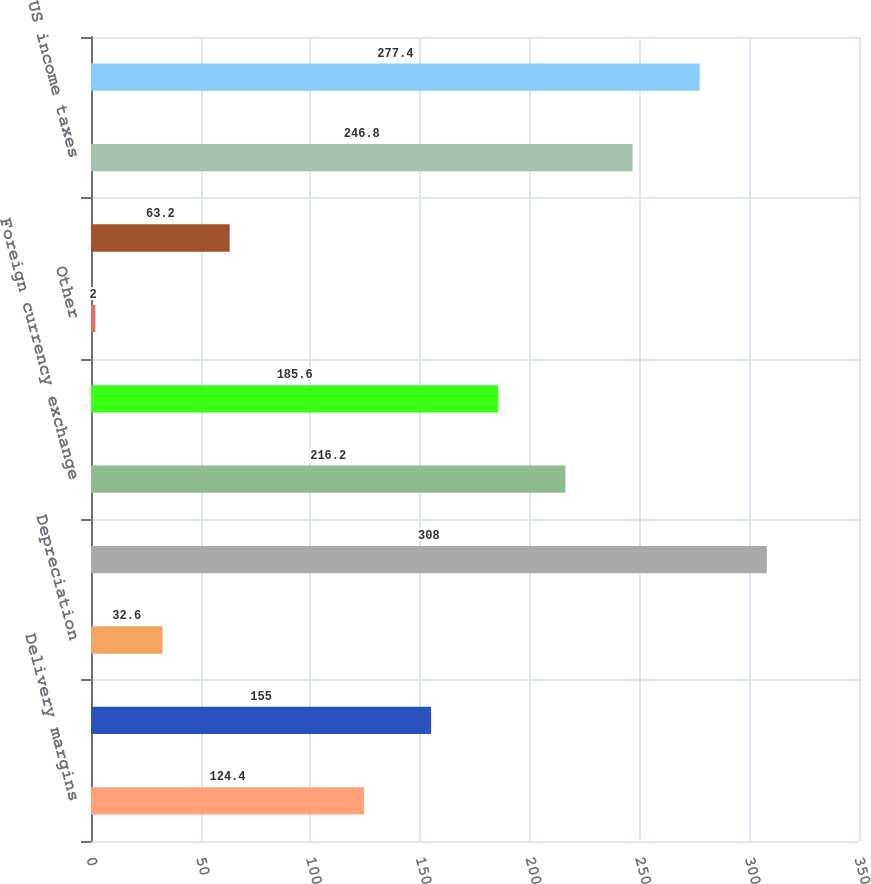Convert chart to OTSL. <chart><loc_0><loc_0><loc_500><loc_500><bar_chart><fcel>Delivery margins<fcel>Other operating expenses<fcel>Depreciation<fcel>Income taxes<fcel>Foreign currency exchange<fcel>Hyder liquidation<fcel>Other<fcel>Discontinued Operations net of<fcel>US income taxes<fcel>Change in tax reserves (Note<nl><fcel>124.4<fcel>155<fcel>32.6<fcel>308<fcel>216.2<fcel>185.6<fcel>2<fcel>63.2<fcel>246.8<fcel>277.4<nl></chart> 